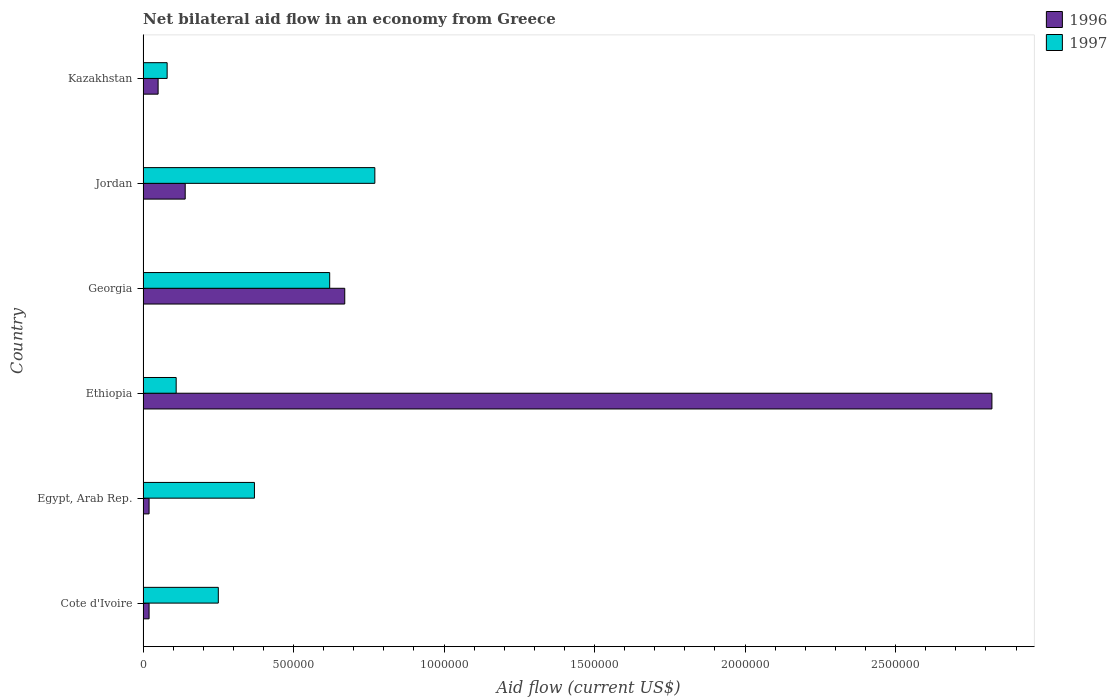How many different coloured bars are there?
Provide a short and direct response. 2. Are the number of bars per tick equal to the number of legend labels?
Keep it short and to the point. Yes. Are the number of bars on each tick of the Y-axis equal?
Your answer should be very brief. Yes. How many bars are there on the 1st tick from the top?
Your answer should be very brief. 2. How many bars are there on the 2nd tick from the bottom?
Provide a succinct answer. 2. What is the label of the 3rd group of bars from the top?
Provide a short and direct response. Georgia. In how many cases, is the number of bars for a given country not equal to the number of legend labels?
Offer a very short reply. 0. What is the net bilateral aid flow in 1996 in Ethiopia?
Make the answer very short. 2.82e+06. Across all countries, what is the maximum net bilateral aid flow in 1996?
Offer a very short reply. 2.82e+06. Across all countries, what is the minimum net bilateral aid flow in 1996?
Provide a succinct answer. 2.00e+04. In which country was the net bilateral aid flow in 1996 maximum?
Your response must be concise. Ethiopia. In which country was the net bilateral aid flow in 1996 minimum?
Offer a very short reply. Cote d'Ivoire. What is the total net bilateral aid flow in 1996 in the graph?
Your response must be concise. 3.72e+06. What is the difference between the net bilateral aid flow in 1996 in Cote d'Ivoire and that in Jordan?
Your response must be concise. -1.20e+05. What is the difference between the net bilateral aid flow in 1996 in Egypt, Arab Rep. and the net bilateral aid flow in 1997 in Cote d'Ivoire?
Offer a very short reply. -2.30e+05. What is the average net bilateral aid flow in 1996 per country?
Make the answer very short. 6.20e+05. What is the difference between the net bilateral aid flow in 1996 and net bilateral aid flow in 1997 in Ethiopia?
Ensure brevity in your answer.  2.71e+06. What is the ratio of the net bilateral aid flow in 1997 in Egypt, Arab Rep. to that in Kazakhstan?
Your answer should be compact. 4.62. Is the net bilateral aid flow in 1996 in Cote d'Ivoire less than that in Ethiopia?
Ensure brevity in your answer.  Yes. Is the difference between the net bilateral aid flow in 1996 in Cote d'Ivoire and Kazakhstan greater than the difference between the net bilateral aid flow in 1997 in Cote d'Ivoire and Kazakhstan?
Your answer should be very brief. No. What is the difference between the highest and the lowest net bilateral aid flow in 1996?
Provide a short and direct response. 2.80e+06. What does the 1st bar from the bottom in Egypt, Arab Rep. represents?
Keep it short and to the point. 1996. Are all the bars in the graph horizontal?
Your answer should be compact. Yes. Does the graph contain grids?
Provide a succinct answer. No. Where does the legend appear in the graph?
Your answer should be compact. Top right. How many legend labels are there?
Make the answer very short. 2. How are the legend labels stacked?
Make the answer very short. Vertical. What is the title of the graph?
Ensure brevity in your answer.  Net bilateral aid flow in an economy from Greece. Does "1973" appear as one of the legend labels in the graph?
Your response must be concise. No. What is the label or title of the X-axis?
Provide a short and direct response. Aid flow (current US$). What is the Aid flow (current US$) of 1996 in Cote d'Ivoire?
Give a very brief answer. 2.00e+04. What is the Aid flow (current US$) of 1996 in Ethiopia?
Provide a succinct answer. 2.82e+06. What is the Aid flow (current US$) in 1996 in Georgia?
Offer a very short reply. 6.70e+05. What is the Aid flow (current US$) in 1997 in Georgia?
Offer a very short reply. 6.20e+05. What is the Aid flow (current US$) of 1997 in Jordan?
Your response must be concise. 7.70e+05. What is the Aid flow (current US$) in 1996 in Kazakhstan?
Offer a terse response. 5.00e+04. What is the Aid flow (current US$) of 1997 in Kazakhstan?
Your answer should be very brief. 8.00e+04. Across all countries, what is the maximum Aid flow (current US$) of 1996?
Provide a succinct answer. 2.82e+06. Across all countries, what is the maximum Aid flow (current US$) of 1997?
Ensure brevity in your answer.  7.70e+05. Across all countries, what is the minimum Aid flow (current US$) of 1997?
Keep it short and to the point. 8.00e+04. What is the total Aid flow (current US$) of 1996 in the graph?
Ensure brevity in your answer.  3.72e+06. What is the total Aid flow (current US$) in 1997 in the graph?
Keep it short and to the point. 2.20e+06. What is the difference between the Aid flow (current US$) of 1996 in Cote d'Ivoire and that in Egypt, Arab Rep.?
Your answer should be very brief. 0. What is the difference between the Aid flow (current US$) in 1996 in Cote d'Ivoire and that in Ethiopia?
Provide a succinct answer. -2.80e+06. What is the difference between the Aid flow (current US$) of 1997 in Cote d'Ivoire and that in Ethiopia?
Keep it short and to the point. 1.40e+05. What is the difference between the Aid flow (current US$) of 1996 in Cote d'Ivoire and that in Georgia?
Offer a terse response. -6.50e+05. What is the difference between the Aid flow (current US$) in 1997 in Cote d'Ivoire and that in Georgia?
Provide a short and direct response. -3.70e+05. What is the difference between the Aid flow (current US$) of 1997 in Cote d'Ivoire and that in Jordan?
Ensure brevity in your answer.  -5.20e+05. What is the difference between the Aid flow (current US$) in 1996 in Cote d'Ivoire and that in Kazakhstan?
Keep it short and to the point. -3.00e+04. What is the difference between the Aid flow (current US$) in 1996 in Egypt, Arab Rep. and that in Ethiopia?
Your response must be concise. -2.80e+06. What is the difference between the Aid flow (current US$) of 1996 in Egypt, Arab Rep. and that in Georgia?
Ensure brevity in your answer.  -6.50e+05. What is the difference between the Aid flow (current US$) of 1997 in Egypt, Arab Rep. and that in Georgia?
Make the answer very short. -2.50e+05. What is the difference between the Aid flow (current US$) in 1997 in Egypt, Arab Rep. and that in Jordan?
Your answer should be compact. -4.00e+05. What is the difference between the Aid flow (current US$) in 1996 in Egypt, Arab Rep. and that in Kazakhstan?
Your response must be concise. -3.00e+04. What is the difference between the Aid flow (current US$) in 1996 in Ethiopia and that in Georgia?
Keep it short and to the point. 2.15e+06. What is the difference between the Aid flow (current US$) in 1997 in Ethiopia and that in Georgia?
Offer a very short reply. -5.10e+05. What is the difference between the Aid flow (current US$) in 1996 in Ethiopia and that in Jordan?
Provide a succinct answer. 2.68e+06. What is the difference between the Aid flow (current US$) in 1997 in Ethiopia and that in Jordan?
Make the answer very short. -6.60e+05. What is the difference between the Aid flow (current US$) in 1996 in Ethiopia and that in Kazakhstan?
Offer a terse response. 2.77e+06. What is the difference between the Aid flow (current US$) of 1997 in Ethiopia and that in Kazakhstan?
Offer a terse response. 3.00e+04. What is the difference between the Aid flow (current US$) of 1996 in Georgia and that in Jordan?
Keep it short and to the point. 5.30e+05. What is the difference between the Aid flow (current US$) of 1997 in Georgia and that in Jordan?
Provide a short and direct response. -1.50e+05. What is the difference between the Aid flow (current US$) of 1996 in Georgia and that in Kazakhstan?
Your answer should be very brief. 6.20e+05. What is the difference between the Aid flow (current US$) in 1997 in Georgia and that in Kazakhstan?
Your response must be concise. 5.40e+05. What is the difference between the Aid flow (current US$) in 1996 in Jordan and that in Kazakhstan?
Make the answer very short. 9.00e+04. What is the difference between the Aid flow (current US$) of 1997 in Jordan and that in Kazakhstan?
Provide a short and direct response. 6.90e+05. What is the difference between the Aid flow (current US$) of 1996 in Cote d'Ivoire and the Aid flow (current US$) of 1997 in Egypt, Arab Rep.?
Your answer should be compact. -3.50e+05. What is the difference between the Aid flow (current US$) in 1996 in Cote d'Ivoire and the Aid flow (current US$) in 1997 in Georgia?
Ensure brevity in your answer.  -6.00e+05. What is the difference between the Aid flow (current US$) of 1996 in Cote d'Ivoire and the Aid flow (current US$) of 1997 in Jordan?
Make the answer very short. -7.50e+05. What is the difference between the Aid flow (current US$) of 1996 in Cote d'Ivoire and the Aid flow (current US$) of 1997 in Kazakhstan?
Your answer should be very brief. -6.00e+04. What is the difference between the Aid flow (current US$) in 1996 in Egypt, Arab Rep. and the Aid flow (current US$) in 1997 in Ethiopia?
Provide a succinct answer. -9.00e+04. What is the difference between the Aid flow (current US$) of 1996 in Egypt, Arab Rep. and the Aid flow (current US$) of 1997 in Georgia?
Give a very brief answer. -6.00e+05. What is the difference between the Aid flow (current US$) of 1996 in Egypt, Arab Rep. and the Aid flow (current US$) of 1997 in Jordan?
Your answer should be very brief. -7.50e+05. What is the difference between the Aid flow (current US$) in 1996 in Ethiopia and the Aid flow (current US$) in 1997 in Georgia?
Offer a terse response. 2.20e+06. What is the difference between the Aid flow (current US$) in 1996 in Ethiopia and the Aid flow (current US$) in 1997 in Jordan?
Your response must be concise. 2.05e+06. What is the difference between the Aid flow (current US$) in 1996 in Ethiopia and the Aid flow (current US$) in 1997 in Kazakhstan?
Offer a very short reply. 2.74e+06. What is the difference between the Aid flow (current US$) of 1996 in Georgia and the Aid flow (current US$) of 1997 in Kazakhstan?
Provide a succinct answer. 5.90e+05. What is the difference between the Aid flow (current US$) of 1996 in Jordan and the Aid flow (current US$) of 1997 in Kazakhstan?
Keep it short and to the point. 6.00e+04. What is the average Aid flow (current US$) of 1996 per country?
Provide a succinct answer. 6.20e+05. What is the average Aid flow (current US$) of 1997 per country?
Make the answer very short. 3.67e+05. What is the difference between the Aid flow (current US$) of 1996 and Aid flow (current US$) of 1997 in Cote d'Ivoire?
Provide a succinct answer. -2.30e+05. What is the difference between the Aid flow (current US$) of 1996 and Aid flow (current US$) of 1997 in Egypt, Arab Rep.?
Give a very brief answer. -3.50e+05. What is the difference between the Aid flow (current US$) in 1996 and Aid flow (current US$) in 1997 in Ethiopia?
Provide a short and direct response. 2.71e+06. What is the difference between the Aid flow (current US$) of 1996 and Aid flow (current US$) of 1997 in Jordan?
Offer a terse response. -6.30e+05. What is the difference between the Aid flow (current US$) in 1996 and Aid flow (current US$) in 1997 in Kazakhstan?
Provide a succinct answer. -3.00e+04. What is the ratio of the Aid flow (current US$) in 1997 in Cote d'Ivoire to that in Egypt, Arab Rep.?
Your answer should be very brief. 0.68. What is the ratio of the Aid flow (current US$) of 1996 in Cote d'Ivoire to that in Ethiopia?
Provide a short and direct response. 0.01. What is the ratio of the Aid flow (current US$) in 1997 in Cote d'Ivoire to that in Ethiopia?
Your response must be concise. 2.27. What is the ratio of the Aid flow (current US$) of 1996 in Cote d'Ivoire to that in Georgia?
Offer a terse response. 0.03. What is the ratio of the Aid flow (current US$) of 1997 in Cote d'Ivoire to that in Georgia?
Offer a very short reply. 0.4. What is the ratio of the Aid flow (current US$) of 1996 in Cote d'Ivoire to that in Jordan?
Your answer should be very brief. 0.14. What is the ratio of the Aid flow (current US$) of 1997 in Cote d'Ivoire to that in Jordan?
Make the answer very short. 0.32. What is the ratio of the Aid flow (current US$) of 1997 in Cote d'Ivoire to that in Kazakhstan?
Your answer should be compact. 3.12. What is the ratio of the Aid flow (current US$) of 1996 in Egypt, Arab Rep. to that in Ethiopia?
Provide a short and direct response. 0.01. What is the ratio of the Aid flow (current US$) in 1997 in Egypt, Arab Rep. to that in Ethiopia?
Ensure brevity in your answer.  3.36. What is the ratio of the Aid flow (current US$) of 1996 in Egypt, Arab Rep. to that in Georgia?
Provide a succinct answer. 0.03. What is the ratio of the Aid flow (current US$) in 1997 in Egypt, Arab Rep. to that in Georgia?
Provide a short and direct response. 0.6. What is the ratio of the Aid flow (current US$) in 1996 in Egypt, Arab Rep. to that in Jordan?
Your answer should be very brief. 0.14. What is the ratio of the Aid flow (current US$) in 1997 in Egypt, Arab Rep. to that in Jordan?
Your answer should be very brief. 0.48. What is the ratio of the Aid flow (current US$) of 1997 in Egypt, Arab Rep. to that in Kazakhstan?
Provide a short and direct response. 4.62. What is the ratio of the Aid flow (current US$) in 1996 in Ethiopia to that in Georgia?
Your response must be concise. 4.21. What is the ratio of the Aid flow (current US$) of 1997 in Ethiopia to that in Georgia?
Provide a succinct answer. 0.18. What is the ratio of the Aid flow (current US$) in 1996 in Ethiopia to that in Jordan?
Your answer should be compact. 20.14. What is the ratio of the Aid flow (current US$) in 1997 in Ethiopia to that in Jordan?
Provide a succinct answer. 0.14. What is the ratio of the Aid flow (current US$) of 1996 in Ethiopia to that in Kazakhstan?
Provide a short and direct response. 56.4. What is the ratio of the Aid flow (current US$) in 1997 in Ethiopia to that in Kazakhstan?
Offer a very short reply. 1.38. What is the ratio of the Aid flow (current US$) in 1996 in Georgia to that in Jordan?
Ensure brevity in your answer.  4.79. What is the ratio of the Aid flow (current US$) of 1997 in Georgia to that in Jordan?
Your answer should be compact. 0.81. What is the ratio of the Aid flow (current US$) in 1996 in Georgia to that in Kazakhstan?
Provide a succinct answer. 13.4. What is the ratio of the Aid flow (current US$) in 1997 in Georgia to that in Kazakhstan?
Your response must be concise. 7.75. What is the ratio of the Aid flow (current US$) in 1997 in Jordan to that in Kazakhstan?
Offer a terse response. 9.62. What is the difference between the highest and the second highest Aid flow (current US$) in 1996?
Ensure brevity in your answer.  2.15e+06. What is the difference between the highest and the second highest Aid flow (current US$) of 1997?
Offer a very short reply. 1.50e+05. What is the difference between the highest and the lowest Aid flow (current US$) in 1996?
Make the answer very short. 2.80e+06. What is the difference between the highest and the lowest Aid flow (current US$) in 1997?
Make the answer very short. 6.90e+05. 